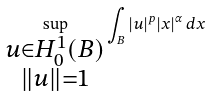<formula> <loc_0><loc_0><loc_500><loc_500>\sup _ { \substack { u \in H _ { 0 } ^ { 1 } ( B ) \\ \| u \| = 1 } } \int _ { B } | u | ^ { p } | x | ^ { \alpha } \, d x</formula> 